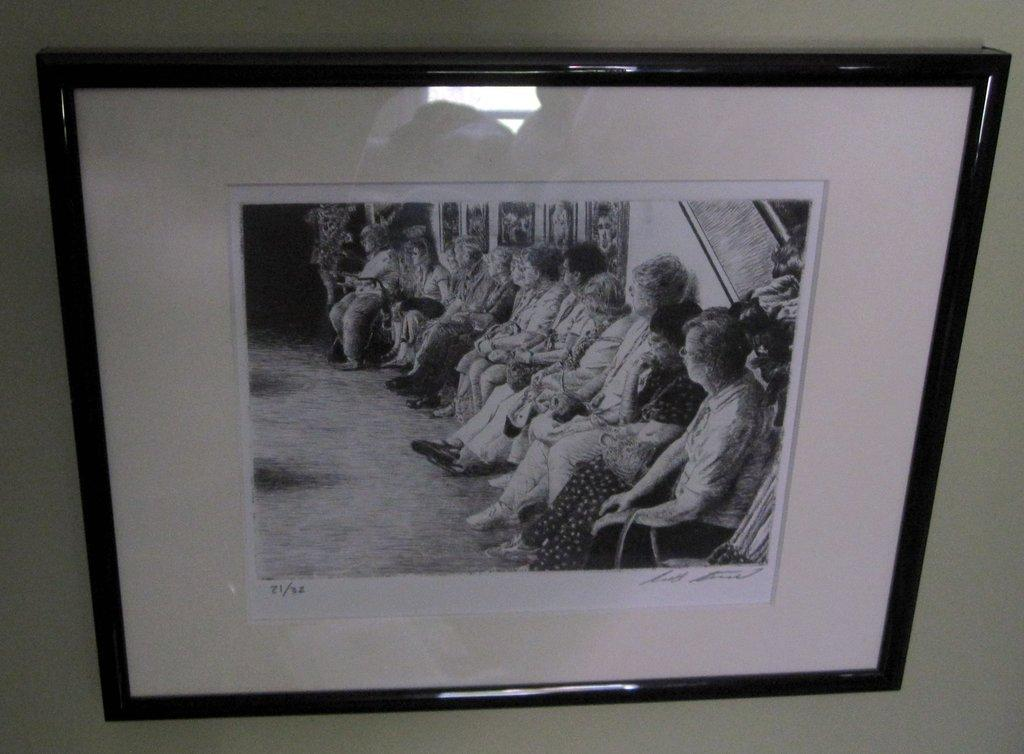<image>
Describe the image concisely. a photo that has the number 21 on it 